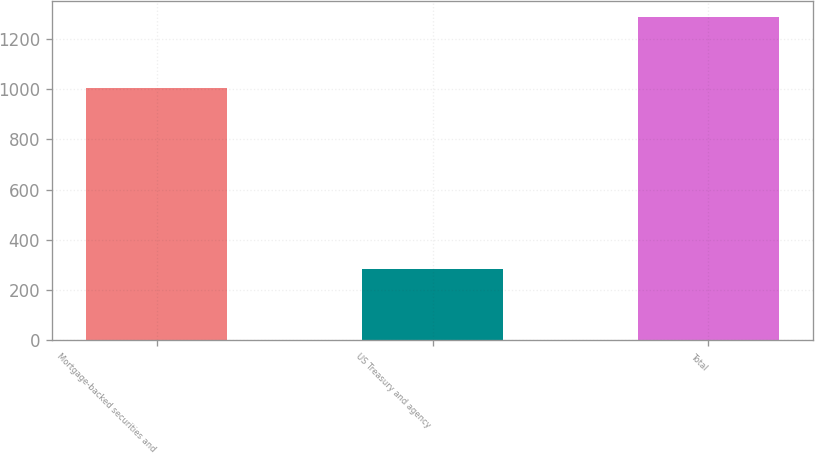Convert chart. <chart><loc_0><loc_0><loc_500><loc_500><bar_chart><fcel>Mortgage-backed securities and<fcel>US Treasury and agency<fcel>Total<nl><fcel>1004.5<fcel>283.3<fcel>1287.8<nl></chart> 